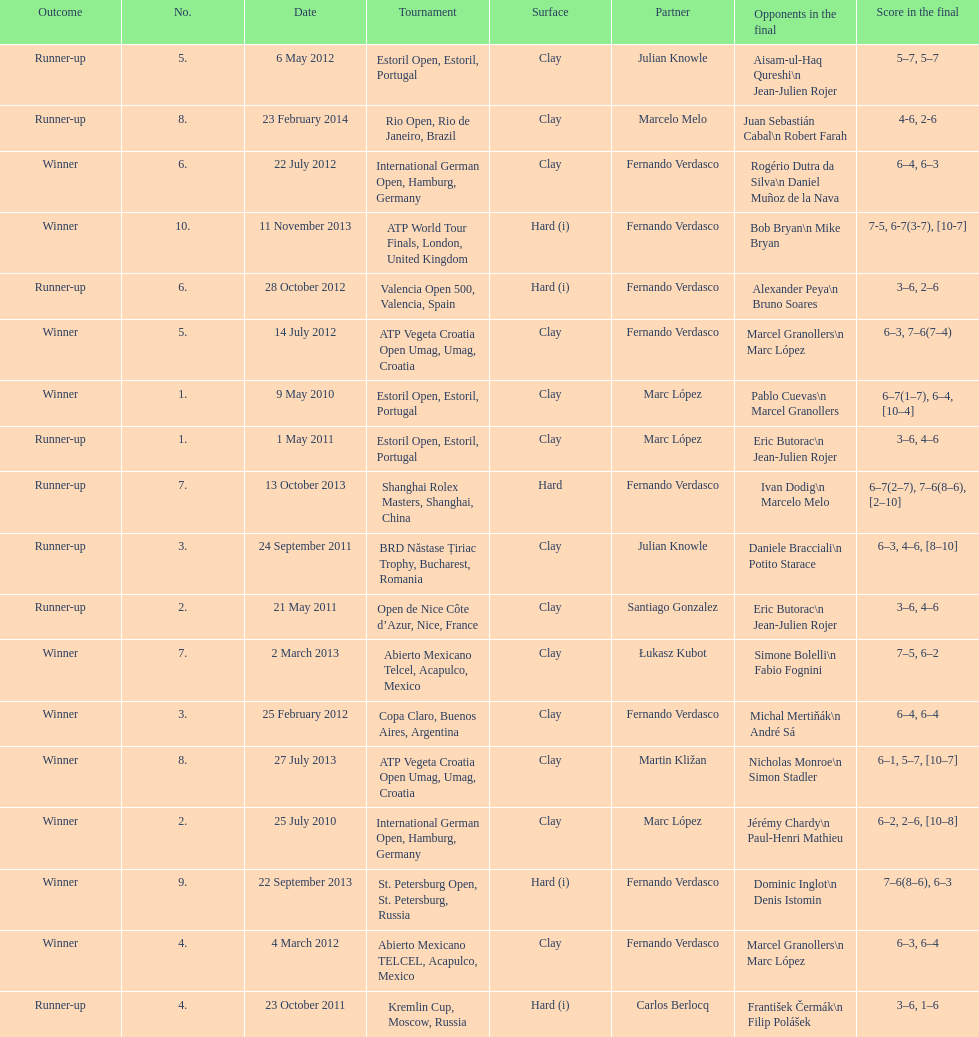What tournament was before the estoril open? Abierto Mexicano TELCEL, Acapulco, Mexico. 